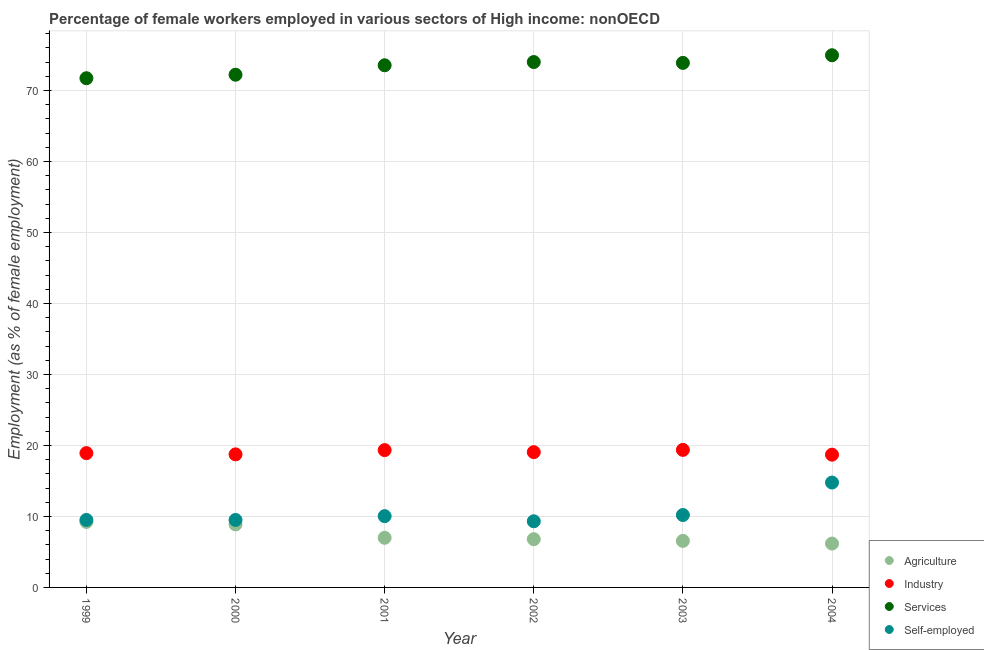What is the percentage of female workers in services in 2000?
Your answer should be compact. 72.21. Across all years, what is the maximum percentage of female workers in agriculture?
Keep it short and to the point. 9.22. Across all years, what is the minimum percentage of female workers in agriculture?
Offer a very short reply. 6.18. In which year was the percentage of female workers in industry minimum?
Offer a very short reply. 2004. What is the total percentage of female workers in agriculture in the graph?
Your answer should be compact. 44.62. What is the difference between the percentage of female workers in industry in 1999 and that in 2002?
Your answer should be very brief. -0.14. What is the difference between the percentage of self employed female workers in 2003 and the percentage of female workers in agriculture in 2001?
Your answer should be very brief. 3.21. What is the average percentage of female workers in agriculture per year?
Provide a short and direct response. 7.44. In the year 2001, what is the difference between the percentage of self employed female workers and percentage of female workers in services?
Provide a short and direct response. -63.5. In how many years, is the percentage of self employed female workers greater than 52 %?
Your response must be concise. 0. What is the ratio of the percentage of female workers in services in 2001 to that in 2002?
Give a very brief answer. 0.99. Is the percentage of female workers in agriculture in 1999 less than that in 2003?
Your response must be concise. No. Is the difference between the percentage of self employed female workers in 2000 and 2004 greater than the difference between the percentage of female workers in industry in 2000 and 2004?
Your answer should be compact. No. What is the difference between the highest and the second highest percentage of female workers in industry?
Ensure brevity in your answer.  0.03. What is the difference between the highest and the lowest percentage of self employed female workers?
Provide a short and direct response. 5.46. Does the percentage of female workers in industry monotonically increase over the years?
Give a very brief answer. No. Is the percentage of female workers in industry strictly greater than the percentage of female workers in services over the years?
Provide a succinct answer. No. How many years are there in the graph?
Keep it short and to the point. 6. Does the graph contain any zero values?
Offer a terse response. No. How many legend labels are there?
Keep it short and to the point. 4. How are the legend labels stacked?
Provide a succinct answer. Vertical. What is the title of the graph?
Offer a terse response. Percentage of female workers employed in various sectors of High income: nonOECD. What is the label or title of the X-axis?
Keep it short and to the point. Year. What is the label or title of the Y-axis?
Provide a succinct answer. Employment (as % of female employment). What is the Employment (as % of female employment) in Agriculture in 1999?
Make the answer very short. 9.22. What is the Employment (as % of female employment) in Industry in 1999?
Your response must be concise. 18.91. What is the Employment (as % of female employment) of Services in 1999?
Offer a terse response. 71.72. What is the Employment (as % of female employment) in Self-employed in 1999?
Provide a short and direct response. 9.5. What is the Employment (as % of female employment) in Agriculture in 2000?
Keep it short and to the point. 8.88. What is the Employment (as % of female employment) in Industry in 2000?
Your response must be concise. 18.74. What is the Employment (as % of female employment) of Services in 2000?
Provide a succinct answer. 72.21. What is the Employment (as % of female employment) in Self-employed in 2000?
Your response must be concise. 9.51. What is the Employment (as % of female employment) of Agriculture in 2001?
Your answer should be compact. 6.99. What is the Employment (as % of female employment) of Industry in 2001?
Your answer should be compact. 19.34. What is the Employment (as % of female employment) in Services in 2001?
Your answer should be compact. 73.54. What is the Employment (as % of female employment) in Self-employed in 2001?
Your response must be concise. 10.04. What is the Employment (as % of female employment) of Agriculture in 2002?
Your response must be concise. 6.8. What is the Employment (as % of female employment) of Industry in 2002?
Ensure brevity in your answer.  19.05. What is the Employment (as % of female employment) in Services in 2002?
Ensure brevity in your answer.  74. What is the Employment (as % of female employment) in Self-employed in 2002?
Provide a succinct answer. 9.31. What is the Employment (as % of female employment) of Agriculture in 2003?
Provide a short and direct response. 6.55. What is the Employment (as % of female employment) in Industry in 2003?
Ensure brevity in your answer.  19.37. What is the Employment (as % of female employment) in Services in 2003?
Offer a terse response. 73.87. What is the Employment (as % of female employment) of Self-employed in 2003?
Make the answer very short. 10.2. What is the Employment (as % of female employment) in Agriculture in 2004?
Make the answer very short. 6.18. What is the Employment (as % of female employment) in Industry in 2004?
Your response must be concise. 18.7. What is the Employment (as % of female employment) of Services in 2004?
Offer a very short reply. 74.95. What is the Employment (as % of female employment) of Self-employed in 2004?
Offer a terse response. 14.77. Across all years, what is the maximum Employment (as % of female employment) in Agriculture?
Provide a short and direct response. 9.22. Across all years, what is the maximum Employment (as % of female employment) of Industry?
Give a very brief answer. 19.37. Across all years, what is the maximum Employment (as % of female employment) of Services?
Offer a terse response. 74.95. Across all years, what is the maximum Employment (as % of female employment) of Self-employed?
Your answer should be compact. 14.77. Across all years, what is the minimum Employment (as % of female employment) in Agriculture?
Your response must be concise. 6.18. Across all years, what is the minimum Employment (as % of female employment) of Industry?
Keep it short and to the point. 18.7. Across all years, what is the minimum Employment (as % of female employment) in Services?
Provide a succinct answer. 71.72. Across all years, what is the minimum Employment (as % of female employment) in Self-employed?
Your response must be concise. 9.31. What is the total Employment (as % of female employment) in Agriculture in the graph?
Offer a very short reply. 44.62. What is the total Employment (as % of female employment) in Industry in the graph?
Provide a short and direct response. 114.11. What is the total Employment (as % of female employment) of Services in the graph?
Your answer should be compact. 440.29. What is the total Employment (as % of female employment) in Self-employed in the graph?
Give a very brief answer. 63.34. What is the difference between the Employment (as % of female employment) of Agriculture in 1999 and that in 2000?
Your answer should be very brief. 0.34. What is the difference between the Employment (as % of female employment) of Industry in 1999 and that in 2000?
Keep it short and to the point. 0.18. What is the difference between the Employment (as % of female employment) of Services in 1999 and that in 2000?
Offer a very short reply. -0.49. What is the difference between the Employment (as % of female employment) in Self-employed in 1999 and that in 2000?
Offer a very short reply. -0. What is the difference between the Employment (as % of female employment) in Agriculture in 1999 and that in 2001?
Make the answer very short. 2.23. What is the difference between the Employment (as % of female employment) in Industry in 1999 and that in 2001?
Your answer should be very brief. -0.43. What is the difference between the Employment (as % of female employment) in Services in 1999 and that in 2001?
Keep it short and to the point. -1.82. What is the difference between the Employment (as % of female employment) of Self-employed in 1999 and that in 2001?
Ensure brevity in your answer.  -0.54. What is the difference between the Employment (as % of female employment) of Agriculture in 1999 and that in 2002?
Offer a terse response. 2.43. What is the difference between the Employment (as % of female employment) in Industry in 1999 and that in 2002?
Your response must be concise. -0.14. What is the difference between the Employment (as % of female employment) in Services in 1999 and that in 2002?
Your answer should be very brief. -2.28. What is the difference between the Employment (as % of female employment) of Self-employed in 1999 and that in 2002?
Your answer should be compact. 0.19. What is the difference between the Employment (as % of female employment) in Agriculture in 1999 and that in 2003?
Ensure brevity in your answer.  2.67. What is the difference between the Employment (as % of female employment) in Industry in 1999 and that in 2003?
Ensure brevity in your answer.  -0.46. What is the difference between the Employment (as % of female employment) of Services in 1999 and that in 2003?
Give a very brief answer. -2.16. What is the difference between the Employment (as % of female employment) in Self-employed in 1999 and that in 2003?
Offer a very short reply. -0.69. What is the difference between the Employment (as % of female employment) of Agriculture in 1999 and that in 2004?
Provide a short and direct response. 3.04. What is the difference between the Employment (as % of female employment) of Industry in 1999 and that in 2004?
Your answer should be compact. 0.22. What is the difference between the Employment (as % of female employment) of Services in 1999 and that in 2004?
Your answer should be very brief. -3.24. What is the difference between the Employment (as % of female employment) of Self-employed in 1999 and that in 2004?
Provide a succinct answer. -5.27. What is the difference between the Employment (as % of female employment) in Agriculture in 2000 and that in 2001?
Offer a very short reply. 1.89. What is the difference between the Employment (as % of female employment) of Industry in 2000 and that in 2001?
Offer a terse response. -0.6. What is the difference between the Employment (as % of female employment) of Services in 2000 and that in 2001?
Your answer should be compact. -1.33. What is the difference between the Employment (as % of female employment) of Self-employed in 2000 and that in 2001?
Provide a succinct answer. -0.54. What is the difference between the Employment (as % of female employment) of Agriculture in 2000 and that in 2002?
Your answer should be very brief. 2.08. What is the difference between the Employment (as % of female employment) of Industry in 2000 and that in 2002?
Your answer should be very brief. -0.31. What is the difference between the Employment (as % of female employment) in Services in 2000 and that in 2002?
Offer a very short reply. -1.79. What is the difference between the Employment (as % of female employment) in Self-employed in 2000 and that in 2002?
Ensure brevity in your answer.  0.19. What is the difference between the Employment (as % of female employment) of Agriculture in 2000 and that in 2003?
Your response must be concise. 2.32. What is the difference between the Employment (as % of female employment) of Industry in 2000 and that in 2003?
Your answer should be very brief. -0.63. What is the difference between the Employment (as % of female employment) of Services in 2000 and that in 2003?
Offer a terse response. -1.67. What is the difference between the Employment (as % of female employment) in Self-employed in 2000 and that in 2003?
Make the answer very short. -0.69. What is the difference between the Employment (as % of female employment) in Agriculture in 2000 and that in 2004?
Make the answer very short. 2.7. What is the difference between the Employment (as % of female employment) of Industry in 2000 and that in 2004?
Offer a terse response. 0.04. What is the difference between the Employment (as % of female employment) in Services in 2000 and that in 2004?
Offer a terse response. -2.74. What is the difference between the Employment (as % of female employment) of Self-employed in 2000 and that in 2004?
Give a very brief answer. -5.26. What is the difference between the Employment (as % of female employment) in Agriculture in 2001 and that in 2002?
Your answer should be very brief. 0.19. What is the difference between the Employment (as % of female employment) in Industry in 2001 and that in 2002?
Keep it short and to the point. 0.29. What is the difference between the Employment (as % of female employment) in Services in 2001 and that in 2002?
Your answer should be very brief. -0.46. What is the difference between the Employment (as % of female employment) in Self-employed in 2001 and that in 2002?
Ensure brevity in your answer.  0.73. What is the difference between the Employment (as % of female employment) in Agriculture in 2001 and that in 2003?
Give a very brief answer. 0.43. What is the difference between the Employment (as % of female employment) of Industry in 2001 and that in 2003?
Your response must be concise. -0.03. What is the difference between the Employment (as % of female employment) of Services in 2001 and that in 2003?
Provide a short and direct response. -0.33. What is the difference between the Employment (as % of female employment) in Self-employed in 2001 and that in 2003?
Offer a very short reply. -0.16. What is the difference between the Employment (as % of female employment) in Agriculture in 2001 and that in 2004?
Your response must be concise. 0.81. What is the difference between the Employment (as % of female employment) of Industry in 2001 and that in 2004?
Your answer should be compact. 0.64. What is the difference between the Employment (as % of female employment) of Services in 2001 and that in 2004?
Your answer should be compact. -1.41. What is the difference between the Employment (as % of female employment) in Self-employed in 2001 and that in 2004?
Ensure brevity in your answer.  -4.73. What is the difference between the Employment (as % of female employment) of Agriculture in 2002 and that in 2003?
Provide a short and direct response. 0.24. What is the difference between the Employment (as % of female employment) in Industry in 2002 and that in 2003?
Offer a terse response. -0.32. What is the difference between the Employment (as % of female employment) of Services in 2002 and that in 2003?
Your response must be concise. 0.12. What is the difference between the Employment (as % of female employment) of Self-employed in 2002 and that in 2003?
Give a very brief answer. -0.88. What is the difference between the Employment (as % of female employment) of Agriculture in 2002 and that in 2004?
Provide a succinct answer. 0.62. What is the difference between the Employment (as % of female employment) of Industry in 2002 and that in 2004?
Ensure brevity in your answer.  0.35. What is the difference between the Employment (as % of female employment) in Services in 2002 and that in 2004?
Provide a succinct answer. -0.96. What is the difference between the Employment (as % of female employment) of Self-employed in 2002 and that in 2004?
Your response must be concise. -5.46. What is the difference between the Employment (as % of female employment) in Agriculture in 2003 and that in 2004?
Make the answer very short. 0.38. What is the difference between the Employment (as % of female employment) of Industry in 2003 and that in 2004?
Give a very brief answer. 0.67. What is the difference between the Employment (as % of female employment) in Services in 2003 and that in 2004?
Keep it short and to the point. -1.08. What is the difference between the Employment (as % of female employment) in Self-employed in 2003 and that in 2004?
Keep it short and to the point. -4.57. What is the difference between the Employment (as % of female employment) in Agriculture in 1999 and the Employment (as % of female employment) in Industry in 2000?
Ensure brevity in your answer.  -9.52. What is the difference between the Employment (as % of female employment) of Agriculture in 1999 and the Employment (as % of female employment) of Services in 2000?
Your answer should be very brief. -62.99. What is the difference between the Employment (as % of female employment) in Agriculture in 1999 and the Employment (as % of female employment) in Self-employed in 2000?
Offer a very short reply. -0.29. What is the difference between the Employment (as % of female employment) in Industry in 1999 and the Employment (as % of female employment) in Services in 2000?
Provide a short and direct response. -53.29. What is the difference between the Employment (as % of female employment) in Industry in 1999 and the Employment (as % of female employment) in Self-employed in 2000?
Keep it short and to the point. 9.41. What is the difference between the Employment (as % of female employment) in Services in 1999 and the Employment (as % of female employment) in Self-employed in 2000?
Provide a short and direct response. 62.21. What is the difference between the Employment (as % of female employment) of Agriculture in 1999 and the Employment (as % of female employment) of Industry in 2001?
Give a very brief answer. -10.12. What is the difference between the Employment (as % of female employment) of Agriculture in 1999 and the Employment (as % of female employment) of Services in 2001?
Your response must be concise. -64.32. What is the difference between the Employment (as % of female employment) in Agriculture in 1999 and the Employment (as % of female employment) in Self-employed in 2001?
Make the answer very short. -0.82. What is the difference between the Employment (as % of female employment) of Industry in 1999 and the Employment (as % of female employment) of Services in 2001?
Your response must be concise. -54.63. What is the difference between the Employment (as % of female employment) of Industry in 1999 and the Employment (as % of female employment) of Self-employed in 2001?
Make the answer very short. 8.87. What is the difference between the Employment (as % of female employment) of Services in 1999 and the Employment (as % of female employment) of Self-employed in 2001?
Make the answer very short. 61.68. What is the difference between the Employment (as % of female employment) of Agriculture in 1999 and the Employment (as % of female employment) of Industry in 2002?
Offer a very short reply. -9.83. What is the difference between the Employment (as % of female employment) of Agriculture in 1999 and the Employment (as % of female employment) of Services in 2002?
Your response must be concise. -64.77. What is the difference between the Employment (as % of female employment) in Agriculture in 1999 and the Employment (as % of female employment) in Self-employed in 2002?
Provide a succinct answer. -0.09. What is the difference between the Employment (as % of female employment) of Industry in 1999 and the Employment (as % of female employment) of Services in 2002?
Provide a short and direct response. -55.08. What is the difference between the Employment (as % of female employment) in Services in 1999 and the Employment (as % of female employment) in Self-employed in 2002?
Your answer should be compact. 62.4. What is the difference between the Employment (as % of female employment) in Agriculture in 1999 and the Employment (as % of female employment) in Industry in 2003?
Your answer should be compact. -10.15. What is the difference between the Employment (as % of female employment) of Agriculture in 1999 and the Employment (as % of female employment) of Services in 2003?
Your answer should be very brief. -64.65. What is the difference between the Employment (as % of female employment) of Agriculture in 1999 and the Employment (as % of female employment) of Self-employed in 2003?
Your answer should be very brief. -0.98. What is the difference between the Employment (as % of female employment) in Industry in 1999 and the Employment (as % of female employment) in Services in 2003?
Your answer should be very brief. -54.96. What is the difference between the Employment (as % of female employment) in Industry in 1999 and the Employment (as % of female employment) in Self-employed in 2003?
Provide a short and direct response. 8.72. What is the difference between the Employment (as % of female employment) in Services in 1999 and the Employment (as % of female employment) in Self-employed in 2003?
Your answer should be compact. 61.52. What is the difference between the Employment (as % of female employment) in Agriculture in 1999 and the Employment (as % of female employment) in Industry in 2004?
Give a very brief answer. -9.48. What is the difference between the Employment (as % of female employment) of Agriculture in 1999 and the Employment (as % of female employment) of Services in 2004?
Ensure brevity in your answer.  -65.73. What is the difference between the Employment (as % of female employment) of Agriculture in 1999 and the Employment (as % of female employment) of Self-employed in 2004?
Ensure brevity in your answer.  -5.55. What is the difference between the Employment (as % of female employment) of Industry in 1999 and the Employment (as % of female employment) of Services in 2004?
Your answer should be very brief. -56.04. What is the difference between the Employment (as % of female employment) in Industry in 1999 and the Employment (as % of female employment) in Self-employed in 2004?
Your answer should be compact. 4.14. What is the difference between the Employment (as % of female employment) of Services in 1999 and the Employment (as % of female employment) of Self-employed in 2004?
Offer a very short reply. 56.95. What is the difference between the Employment (as % of female employment) in Agriculture in 2000 and the Employment (as % of female employment) in Industry in 2001?
Ensure brevity in your answer.  -10.46. What is the difference between the Employment (as % of female employment) of Agriculture in 2000 and the Employment (as % of female employment) of Services in 2001?
Provide a succinct answer. -64.66. What is the difference between the Employment (as % of female employment) in Agriculture in 2000 and the Employment (as % of female employment) in Self-employed in 2001?
Ensure brevity in your answer.  -1.16. What is the difference between the Employment (as % of female employment) of Industry in 2000 and the Employment (as % of female employment) of Services in 2001?
Keep it short and to the point. -54.8. What is the difference between the Employment (as % of female employment) of Industry in 2000 and the Employment (as % of female employment) of Self-employed in 2001?
Make the answer very short. 8.7. What is the difference between the Employment (as % of female employment) in Services in 2000 and the Employment (as % of female employment) in Self-employed in 2001?
Provide a short and direct response. 62.17. What is the difference between the Employment (as % of female employment) of Agriculture in 2000 and the Employment (as % of female employment) of Industry in 2002?
Keep it short and to the point. -10.17. What is the difference between the Employment (as % of female employment) in Agriculture in 2000 and the Employment (as % of female employment) in Services in 2002?
Make the answer very short. -65.12. What is the difference between the Employment (as % of female employment) of Agriculture in 2000 and the Employment (as % of female employment) of Self-employed in 2002?
Your response must be concise. -0.44. What is the difference between the Employment (as % of female employment) of Industry in 2000 and the Employment (as % of female employment) of Services in 2002?
Give a very brief answer. -55.26. What is the difference between the Employment (as % of female employment) of Industry in 2000 and the Employment (as % of female employment) of Self-employed in 2002?
Provide a short and direct response. 9.42. What is the difference between the Employment (as % of female employment) of Services in 2000 and the Employment (as % of female employment) of Self-employed in 2002?
Provide a succinct answer. 62.89. What is the difference between the Employment (as % of female employment) of Agriculture in 2000 and the Employment (as % of female employment) of Industry in 2003?
Provide a succinct answer. -10.49. What is the difference between the Employment (as % of female employment) in Agriculture in 2000 and the Employment (as % of female employment) in Services in 2003?
Your answer should be very brief. -65. What is the difference between the Employment (as % of female employment) of Agriculture in 2000 and the Employment (as % of female employment) of Self-employed in 2003?
Offer a very short reply. -1.32. What is the difference between the Employment (as % of female employment) in Industry in 2000 and the Employment (as % of female employment) in Services in 2003?
Your answer should be compact. -55.14. What is the difference between the Employment (as % of female employment) of Industry in 2000 and the Employment (as % of female employment) of Self-employed in 2003?
Your answer should be very brief. 8.54. What is the difference between the Employment (as % of female employment) in Services in 2000 and the Employment (as % of female employment) in Self-employed in 2003?
Offer a very short reply. 62.01. What is the difference between the Employment (as % of female employment) in Agriculture in 2000 and the Employment (as % of female employment) in Industry in 2004?
Offer a very short reply. -9.82. What is the difference between the Employment (as % of female employment) of Agriculture in 2000 and the Employment (as % of female employment) of Services in 2004?
Your answer should be very brief. -66.07. What is the difference between the Employment (as % of female employment) of Agriculture in 2000 and the Employment (as % of female employment) of Self-employed in 2004?
Ensure brevity in your answer.  -5.89. What is the difference between the Employment (as % of female employment) of Industry in 2000 and the Employment (as % of female employment) of Services in 2004?
Provide a succinct answer. -56.21. What is the difference between the Employment (as % of female employment) of Industry in 2000 and the Employment (as % of female employment) of Self-employed in 2004?
Ensure brevity in your answer.  3.97. What is the difference between the Employment (as % of female employment) in Services in 2000 and the Employment (as % of female employment) in Self-employed in 2004?
Your answer should be compact. 57.44. What is the difference between the Employment (as % of female employment) in Agriculture in 2001 and the Employment (as % of female employment) in Industry in 2002?
Offer a very short reply. -12.06. What is the difference between the Employment (as % of female employment) of Agriculture in 2001 and the Employment (as % of female employment) of Services in 2002?
Offer a terse response. -67.01. What is the difference between the Employment (as % of female employment) in Agriculture in 2001 and the Employment (as % of female employment) in Self-employed in 2002?
Make the answer very short. -2.33. What is the difference between the Employment (as % of female employment) in Industry in 2001 and the Employment (as % of female employment) in Services in 2002?
Your response must be concise. -54.65. What is the difference between the Employment (as % of female employment) of Industry in 2001 and the Employment (as % of female employment) of Self-employed in 2002?
Your answer should be very brief. 10.03. What is the difference between the Employment (as % of female employment) in Services in 2001 and the Employment (as % of female employment) in Self-employed in 2002?
Offer a very short reply. 64.23. What is the difference between the Employment (as % of female employment) of Agriculture in 2001 and the Employment (as % of female employment) of Industry in 2003?
Offer a very short reply. -12.38. What is the difference between the Employment (as % of female employment) of Agriculture in 2001 and the Employment (as % of female employment) of Services in 2003?
Give a very brief answer. -66.89. What is the difference between the Employment (as % of female employment) of Agriculture in 2001 and the Employment (as % of female employment) of Self-employed in 2003?
Provide a succinct answer. -3.21. What is the difference between the Employment (as % of female employment) of Industry in 2001 and the Employment (as % of female employment) of Services in 2003?
Offer a terse response. -54.53. What is the difference between the Employment (as % of female employment) in Industry in 2001 and the Employment (as % of female employment) in Self-employed in 2003?
Make the answer very short. 9.14. What is the difference between the Employment (as % of female employment) of Services in 2001 and the Employment (as % of female employment) of Self-employed in 2003?
Your answer should be compact. 63.34. What is the difference between the Employment (as % of female employment) in Agriculture in 2001 and the Employment (as % of female employment) in Industry in 2004?
Your answer should be compact. -11.71. What is the difference between the Employment (as % of female employment) of Agriculture in 2001 and the Employment (as % of female employment) of Services in 2004?
Your response must be concise. -67.96. What is the difference between the Employment (as % of female employment) in Agriculture in 2001 and the Employment (as % of female employment) in Self-employed in 2004?
Keep it short and to the point. -7.78. What is the difference between the Employment (as % of female employment) of Industry in 2001 and the Employment (as % of female employment) of Services in 2004?
Offer a terse response. -55.61. What is the difference between the Employment (as % of female employment) of Industry in 2001 and the Employment (as % of female employment) of Self-employed in 2004?
Ensure brevity in your answer.  4.57. What is the difference between the Employment (as % of female employment) in Services in 2001 and the Employment (as % of female employment) in Self-employed in 2004?
Keep it short and to the point. 58.77. What is the difference between the Employment (as % of female employment) in Agriculture in 2002 and the Employment (as % of female employment) in Industry in 2003?
Provide a succinct answer. -12.58. What is the difference between the Employment (as % of female employment) in Agriculture in 2002 and the Employment (as % of female employment) in Services in 2003?
Keep it short and to the point. -67.08. What is the difference between the Employment (as % of female employment) in Agriculture in 2002 and the Employment (as % of female employment) in Self-employed in 2003?
Provide a succinct answer. -3.4. What is the difference between the Employment (as % of female employment) in Industry in 2002 and the Employment (as % of female employment) in Services in 2003?
Your answer should be very brief. -54.82. What is the difference between the Employment (as % of female employment) in Industry in 2002 and the Employment (as % of female employment) in Self-employed in 2003?
Your answer should be compact. 8.85. What is the difference between the Employment (as % of female employment) of Services in 2002 and the Employment (as % of female employment) of Self-employed in 2003?
Provide a short and direct response. 63.8. What is the difference between the Employment (as % of female employment) in Agriculture in 2002 and the Employment (as % of female employment) in Industry in 2004?
Provide a short and direct response. -11.9. What is the difference between the Employment (as % of female employment) in Agriculture in 2002 and the Employment (as % of female employment) in Services in 2004?
Your answer should be very brief. -68.16. What is the difference between the Employment (as % of female employment) of Agriculture in 2002 and the Employment (as % of female employment) of Self-employed in 2004?
Ensure brevity in your answer.  -7.98. What is the difference between the Employment (as % of female employment) of Industry in 2002 and the Employment (as % of female employment) of Services in 2004?
Ensure brevity in your answer.  -55.9. What is the difference between the Employment (as % of female employment) in Industry in 2002 and the Employment (as % of female employment) in Self-employed in 2004?
Make the answer very short. 4.28. What is the difference between the Employment (as % of female employment) in Services in 2002 and the Employment (as % of female employment) in Self-employed in 2004?
Provide a short and direct response. 59.22. What is the difference between the Employment (as % of female employment) in Agriculture in 2003 and the Employment (as % of female employment) in Industry in 2004?
Provide a short and direct response. -12.14. What is the difference between the Employment (as % of female employment) in Agriculture in 2003 and the Employment (as % of female employment) in Services in 2004?
Your answer should be compact. -68.4. What is the difference between the Employment (as % of female employment) of Agriculture in 2003 and the Employment (as % of female employment) of Self-employed in 2004?
Ensure brevity in your answer.  -8.22. What is the difference between the Employment (as % of female employment) in Industry in 2003 and the Employment (as % of female employment) in Services in 2004?
Give a very brief answer. -55.58. What is the difference between the Employment (as % of female employment) in Industry in 2003 and the Employment (as % of female employment) in Self-employed in 2004?
Ensure brevity in your answer.  4.6. What is the difference between the Employment (as % of female employment) in Services in 2003 and the Employment (as % of female employment) in Self-employed in 2004?
Give a very brief answer. 59.1. What is the average Employment (as % of female employment) in Agriculture per year?
Provide a short and direct response. 7.44. What is the average Employment (as % of female employment) of Industry per year?
Offer a terse response. 19.02. What is the average Employment (as % of female employment) in Services per year?
Give a very brief answer. 73.38. What is the average Employment (as % of female employment) of Self-employed per year?
Your response must be concise. 10.56. In the year 1999, what is the difference between the Employment (as % of female employment) of Agriculture and Employment (as % of female employment) of Industry?
Offer a terse response. -9.69. In the year 1999, what is the difference between the Employment (as % of female employment) in Agriculture and Employment (as % of female employment) in Services?
Make the answer very short. -62.5. In the year 1999, what is the difference between the Employment (as % of female employment) of Agriculture and Employment (as % of female employment) of Self-employed?
Keep it short and to the point. -0.28. In the year 1999, what is the difference between the Employment (as % of female employment) in Industry and Employment (as % of female employment) in Services?
Your answer should be very brief. -52.8. In the year 1999, what is the difference between the Employment (as % of female employment) in Industry and Employment (as % of female employment) in Self-employed?
Provide a succinct answer. 9.41. In the year 1999, what is the difference between the Employment (as % of female employment) of Services and Employment (as % of female employment) of Self-employed?
Provide a short and direct response. 62.21. In the year 2000, what is the difference between the Employment (as % of female employment) of Agriculture and Employment (as % of female employment) of Industry?
Offer a very short reply. -9.86. In the year 2000, what is the difference between the Employment (as % of female employment) in Agriculture and Employment (as % of female employment) in Services?
Your answer should be compact. -63.33. In the year 2000, what is the difference between the Employment (as % of female employment) in Agriculture and Employment (as % of female employment) in Self-employed?
Offer a very short reply. -0.63. In the year 2000, what is the difference between the Employment (as % of female employment) in Industry and Employment (as % of female employment) in Services?
Make the answer very short. -53.47. In the year 2000, what is the difference between the Employment (as % of female employment) in Industry and Employment (as % of female employment) in Self-employed?
Your answer should be very brief. 9.23. In the year 2000, what is the difference between the Employment (as % of female employment) in Services and Employment (as % of female employment) in Self-employed?
Offer a terse response. 62.7. In the year 2001, what is the difference between the Employment (as % of female employment) of Agriculture and Employment (as % of female employment) of Industry?
Provide a short and direct response. -12.35. In the year 2001, what is the difference between the Employment (as % of female employment) of Agriculture and Employment (as % of female employment) of Services?
Your response must be concise. -66.55. In the year 2001, what is the difference between the Employment (as % of female employment) of Agriculture and Employment (as % of female employment) of Self-employed?
Give a very brief answer. -3.05. In the year 2001, what is the difference between the Employment (as % of female employment) in Industry and Employment (as % of female employment) in Services?
Provide a short and direct response. -54.2. In the year 2001, what is the difference between the Employment (as % of female employment) in Industry and Employment (as % of female employment) in Self-employed?
Offer a terse response. 9.3. In the year 2001, what is the difference between the Employment (as % of female employment) of Services and Employment (as % of female employment) of Self-employed?
Make the answer very short. 63.5. In the year 2002, what is the difference between the Employment (as % of female employment) in Agriculture and Employment (as % of female employment) in Industry?
Offer a very short reply. -12.26. In the year 2002, what is the difference between the Employment (as % of female employment) of Agriculture and Employment (as % of female employment) of Services?
Your response must be concise. -67.2. In the year 2002, what is the difference between the Employment (as % of female employment) in Agriculture and Employment (as % of female employment) in Self-employed?
Your answer should be compact. -2.52. In the year 2002, what is the difference between the Employment (as % of female employment) of Industry and Employment (as % of female employment) of Services?
Keep it short and to the point. -54.94. In the year 2002, what is the difference between the Employment (as % of female employment) of Industry and Employment (as % of female employment) of Self-employed?
Your answer should be compact. 9.74. In the year 2002, what is the difference between the Employment (as % of female employment) in Services and Employment (as % of female employment) in Self-employed?
Make the answer very short. 64.68. In the year 2003, what is the difference between the Employment (as % of female employment) in Agriculture and Employment (as % of female employment) in Industry?
Provide a succinct answer. -12.82. In the year 2003, what is the difference between the Employment (as % of female employment) in Agriculture and Employment (as % of female employment) in Services?
Your answer should be very brief. -67.32. In the year 2003, what is the difference between the Employment (as % of female employment) in Agriculture and Employment (as % of female employment) in Self-employed?
Your answer should be compact. -3.64. In the year 2003, what is the difference between the Employment (as % of female employment) in Industry and Employment (as % of female employment) in Services?
Give a very brief answer. -54.5. In the year 2003, what is the difference between the Employment (as % of female employment) in Industry and Employment (as % of female employment) in Self-employed?
Offer a very short reply. 9.17. In the year 2003, what is the difference between the Employment (as % of female employment) of Services and Employment (as % of female employment) of Self-employed?
Ensure brevity in your answer.  63.68. In the year 2004, what is the difference between the Employment (as % of female employment) of Agriculture and Employment (as % of female employment) of Industry?
Give a very brief answer. -12.52. In the year 2004, what is the difference between the Employment (as % of female employment) of Agriculture and Employment (as % of female employment) of Services?
Your answer should be compact. -68.78. In the year 2004, what is the difference between the Employment (as % of female employment) of Agriculture and Employment (as % of female employment) of Self-employed?
Offer a terse response. -8.59. In the year 2004, what is the difference between the Employment (as % of female employment) of Industry and Employment (as % of female employment) of Services?
Ensure brevity in your answer.  -56.26. In the year 2004, what is the difference between the Employment (as % of female employment) of Industry and Employment (as % of female employment) of Self-employed?
Make the answer very short. 3.93. In the year 2004, what is the difference between the Employment (as % of female employment) in Services and Employment (as % of female employment) in Self-employed?
Provide a short and direct response. 60.18. What is the ratio of the Employment (as % of female employment) in Agriculture in 1999 to that in 2000?
Your answer should be compact. 1.04. What is the ratio of the Employment (as % of female employment) in Industry in 1999 to that in 2000?
Make the answer very short. 1.01. What is the ratio of the Employment (as % of female employment) of Services in 1999 to that in 2000?
Make the answer very short. 0.99. What is the ratio of the Employment (as % of female employment) of Self-employed in 1999 to that in 2000?
Keep it short and to the point. 1. What is the ratio of the Employment (as % of female employment) in Agriculture in 1999 to that in 2001?
Ensure brevity in your answer.  1.32. What is the ratio of the Employment (as % of female employment) in Services in 1999 to that in 2001?
Offer a terse response. 0.98. What is the ratio of the Employment (as % of female employment) of Self-employed in 1999 to that in 2001?
Keep it short and to the point. 0.95. What is the ratio of the Employment (as % of female employment) in Agriculture in 1999 to that in 2002?
Provide a short and direct response. 1.36. What is the ratio of the Employment (as % of female employment) of Services in 1999 to that in 2002?
Your response must be concise. 0.97. What is the ratio of the Employment (as % of female employment) of Self-employed in 1999 to that in 2002?
Offer a very short reply. 1.02. What is the ratio of the Employment (as % of female employment) in Agriculture in 1999 to that in 2003?
Provide a succinct answer. 1.41. What is the ratio of the Employment (as % of female employment) in Industry in 1999 to that in 2003?
Your answer should be compact. 0.98. What is the ratio of the Employment (as % of female employment) in Services in 1999 to that in 2003?
Make the answer very short. 0.97. What is the ratio of the Employment (as % of female employment) of Self-employed in 1999 to that in 2003?
Keep it short and to the point. 0.93. What is the ratio of the Employment (as % of female employment) in Agriculture in 1999 to that in 2004?
Your answer should be compact. 1.49. What is the ratio of the Employment (as % of female employment) in Industry in 1999 to that in 2004?
Provide a succinct answer. 1.01. What is the ratio of the Employment (as % of female employment) in Services in 1999 to that in 2004?
Offer a very short reply. 0.96. What is the ratio of the Employment (as % of female employment) in Self-employed in 1999 to that in 2004?
Provide a succinct answer. 0.64. What is the ratio of the Employment (as % of female employment) of Agriculture in 2000 to that in 2001?
Provide a short and direct response. 1.27. What is the ratio of the Employment (as % of female employment) in Industry in 2000 to that in 2001?
Keep it short and to the point. 0.97. What is the ratio of the Employment (as % of female employment) in Services in 2000 to that in 2001?
Ensure brevity in your answer.  0.98. What is the ratio of the Employment (as % of female employment) in Self-employed in 2000 to that in 2001?
Your response must be concise. 0.95. What is the ratio of the Employment (as % of female employment) in Agriculture in 2000 to that in 2002?
Give a very brief answer. 1.31. What is the ratio of the Employment (as % of female employment) of Industry in 2000 to that in 2002?
Keep it short and to the point. 0.98. What is the ratio of the Employment (as % of female employment) in Services in 2000 to that in 2002?
Ensure brevity in your answer.  0.98. What is the ratio of the Employment (as % of female employment) in Self-employed in 2000 to that in 2002?
Offer a very short reply. 1.02. What is the ratio of the Employment (as % of female employment) in Agriculture in 2000 to that in 2003?
Offer a terse response. 1.35. What is the ratio of the Employment (as % of female employment) in Industry in 2000 to that in 2003?
Ensure brevity in your answer.  0.97. What is the ratio of the Employment (as % of female employment) in Services in 2000 to that in 2003?
Offer a terse response. 0.98. What is the ratio of the Employment (as % of female employment) in Self-employed in 2000 to that in 2003?
Your answer should be very brief. 0.93. What is the ratio of the Employment (as % of female employment) in Agriculture in 2000 to that in 2004?
Your response must be concise. 1.44. What is the ratio of the Employment (as % of female employment) of Industry in 2000 to that in 2004?
Offer a very short reply. 1. What is the ratio of the Employment (as % of female employment) of Services in 2000 to that in 2004?
Offer a terse response. 0.96. What is the ratio of the Employment (as % of female employment) in Self-employed in 2000 to that in 2004?
Your answer should be compact. 0.64. What is the ratio of the Employment (as % of female employment) of Agriculture in 2001 to that in 2002?
Offer a terse response. 1.03. What is the ratio of the Employment (as % of female employment) in Industry in 2001 to that in 2002?
Ensure brevity in your answer.  1.02. What is the ratio of the Employment (as % of female employment) of Services in 2001 to that in 2002?
Your answer should be very brief. 0.99. What is the ratio of the Employment (as % of female employment) of Self-employed in 2001 to that in 2002?
Provide a short and direct response. 1.08. What is the ratio of the Employment (as % of female employment) in Agriculture in 2001 to that in 2003?
Provide a short and direct response. 1.07. What is the ratio of the Employment (as % of female employment) of Self-employed in 2001 to that in 2003?
Your answer should be compact. 0.98. What is the ratio of the Employment (as % of female employment) in Agriculture in 2001 to that in 2004?
Offer a very short reply. 1.13. What is the ratio of the Employment (as % of female employment) in Industry in 2001 to that in 2004?
Your response must be concise. 1.03. What is the ratio of the Employment (as % of female employment) in Services in 2001 to that in 2004?
Provide a succinct answer. 0.98. What is the ratio of the Employment (as % of female employment) in Self-employed in 2001 to that in 2004?
Your response must be concise. 0.68. What is the ratio of the Employment (as % of female employment) in Agriculture in 2002 to that in 2003?
Make the answer very short. 1.04. What is the ratio of the Employment (as % of female employment) of Industry in 2002 to that in 2003?
Your response must be concise. 0.98. What is the ratio of the Employment (as % of female employment) of Self-employed in 2002 to that in 2003?
Offer a very short reply. 0.91. What is the ratio of the Employment (as % of female employment) of Agriculture in 2002 to that in 2004?
Your response must be concise. 1.1. What is the ratio of the Employment (as % of female employment) in Industry in 2002 to that in 2004?
Make the answer very short. 1.02. What is the ratio of the Employment (as % of female employment) of Services in 2002 to that in 2004?
Provide a succinct answer. 0.99. What is the ratio of the Employment (as % of female employment) of Self-employed in 2002 to that in 2004?
Your answer should be compact. 0.63. What is the ratio of the Employment (as % of female employment) in Agriculture in 2003 to that in 2004?
Your response must be concise. 1.06. What is the ratio of the Employment (as % of female employment) of Industry in 2003 to that in 2004?
Make the answer very short. 1.04. What is the ratio of the Employment (as % of female employment) of Services in 2003 to that in 2004?
Give a very brief answer. 0.99. What is the ratio of the Employment (as % of female employment) of Self-employed in 2003 to that in 2004?
Keep it short and to the point. 0.69. What is the difference between the highest and the second highest Employment (as % of female employment) in Agriculture?
Your answer should be very brief. 0.34. What is the difference between the highest and the second highest Employment (as % of female employment) in Industry?
Provide a succinct answer. 0.03. What is the difference between the highest and the second highest Employment (as % of female employment) of Services?
Your response must be concise. 0.96. What is the difference between the highest and the second highest Employment (as % of female employment) in Self-employed?
Offer a terse response. 4.57. What is the difference between the highest and the lowest Employment (as % of female employment) in Agriculture?
Make the answer very short. 3.04. What is the difference between the highest and the lowest Employment (as % of female employment) in Industry?
Make the answer very short. 0.67. What is the difference between the highest and the lowest Employment (as % of female employment) of Services?
Provide a succinct answer. 3.24. What is the difference between the highest and the lowest Employment (as % of female employment) of Self-employed?
Keep it short and to the point. 5.46. 